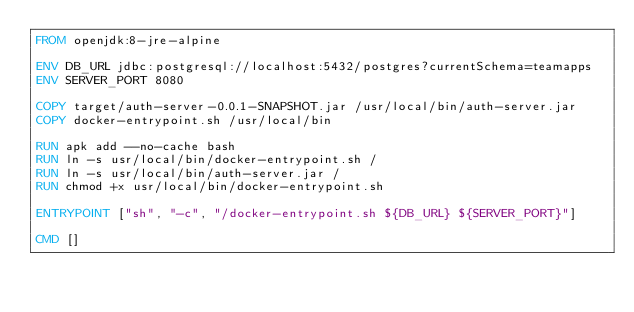<code> <loc_0><loc_0><loc_500><loc_500><_Dockerfile_>FROM openjdk:8-jre-alpine

ENV DB_URL jdbc:postgresql://localhost:5432/postgres?currentSchema=teamapps
ENV SERVER_PORT 8080

COPY target/auth-server-0.0.1-SNAPSHOT.jar /usr/local/bin/auth-server.jar
COPY docker-entrypoint.sh /usr/local/bin

RUN apk add --no-cache bash
RUN ln -s usr/local/bin/docker-entrypoint.sh /
RUN ln -s usr/local/bin/auth-server.jar /
RUN chmod +x usr/local/bin/docker-entrypoint.sh

ENTRYPOINT ["sh", "-c", "/docker-entrypoint.sh ${DB_URL} ${SERVER_PORT}"]

CMD []</code> 